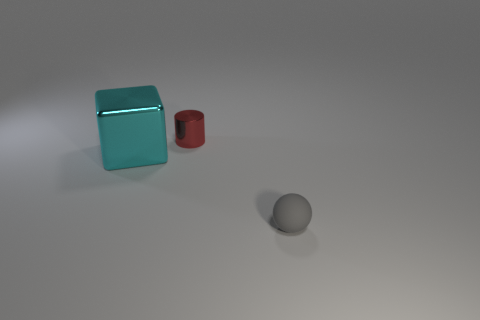Add 3 small rubber cylinders. How many objects exist? 6 Subtract 1 cyan cubes. How many objects are left? 2 Subtract all cylinders. How many objects are left? 2 Subtract all yellow metallic cylinders. Subtract all small red shiny cylinders. How many objects are left? 2 Add 1 small matte objects. How many small matte objects are left? 2 Add 1 gray spheres. How many gray spheres exist? 2 